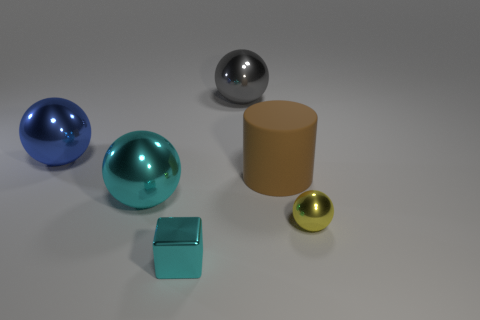Subtract all yellow spheres. How many spheres are left? 3 Subtract all purple balls. Subtract all red blocks. How many balls are left? 4 Add 3 large cylinders. How many objects exist? 9 Subtract all spheres. How many objects are left? 2 Add 5 tiny cyan shiny blocks. How many tiny cyan shiny blocks are left? 6 Add 5 blue shiny spheres. How many blue shiny spheres exist? 6 Subtract 0 gray cylinders. How many objects are left? 6 Subtract all small balls. Subtract all cyan objects. How many objects are left? 3 